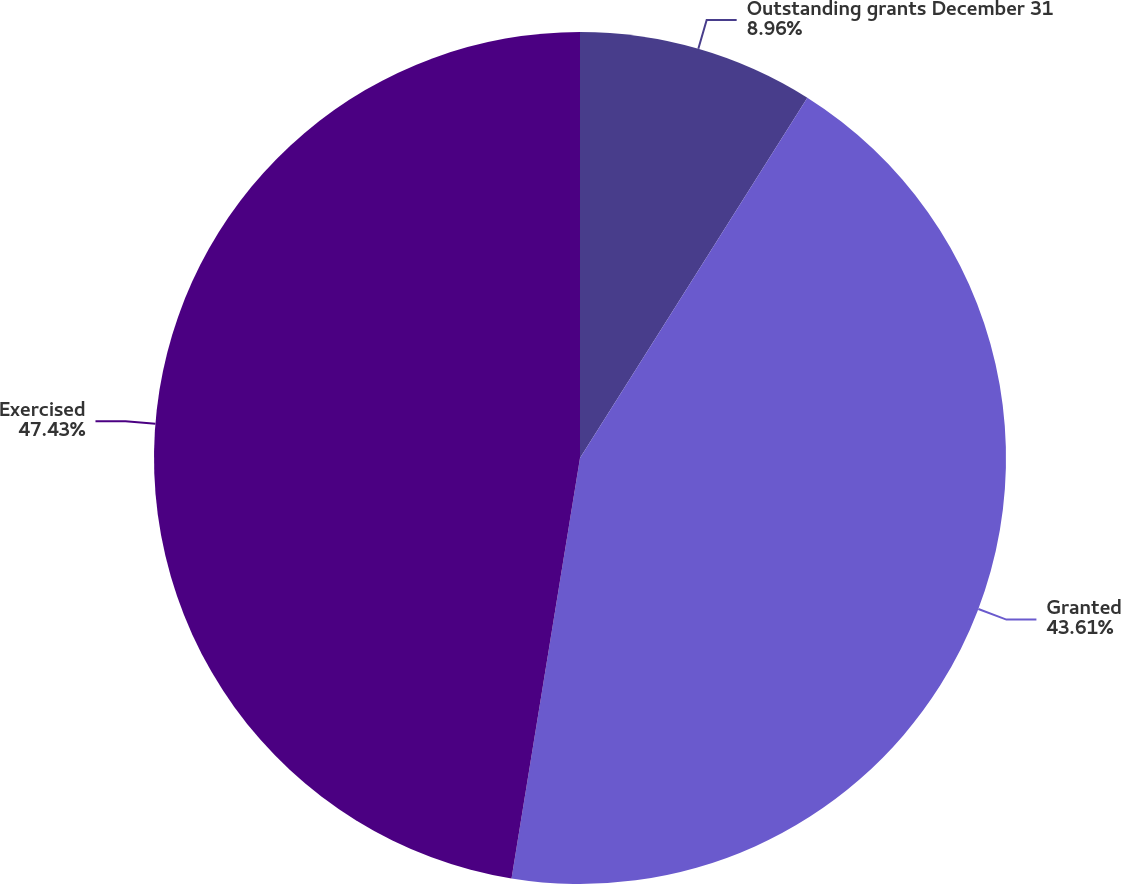Convert chart to OTSL. <chart><loc_0><loc_0><loc_500><loc_500><pie_chart><fcel>Outstanding grants December 31<fcel>Granted<fcel>Exercised<nl><fcel>8.96%<fcel>43.61%<fcel>47.43%<nl></chart> 